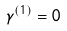<formula> <loc_0><loc_0><loc_500><loc_500>\gamma ^ { ( 1 ) } = 0</formula> 